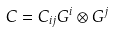Convert formula to latex. <formula><loc_0><loc_0><loc_500><loc_500>C = C _ { i j } G ^ { i } \otimes G ^ { j }</formula> 